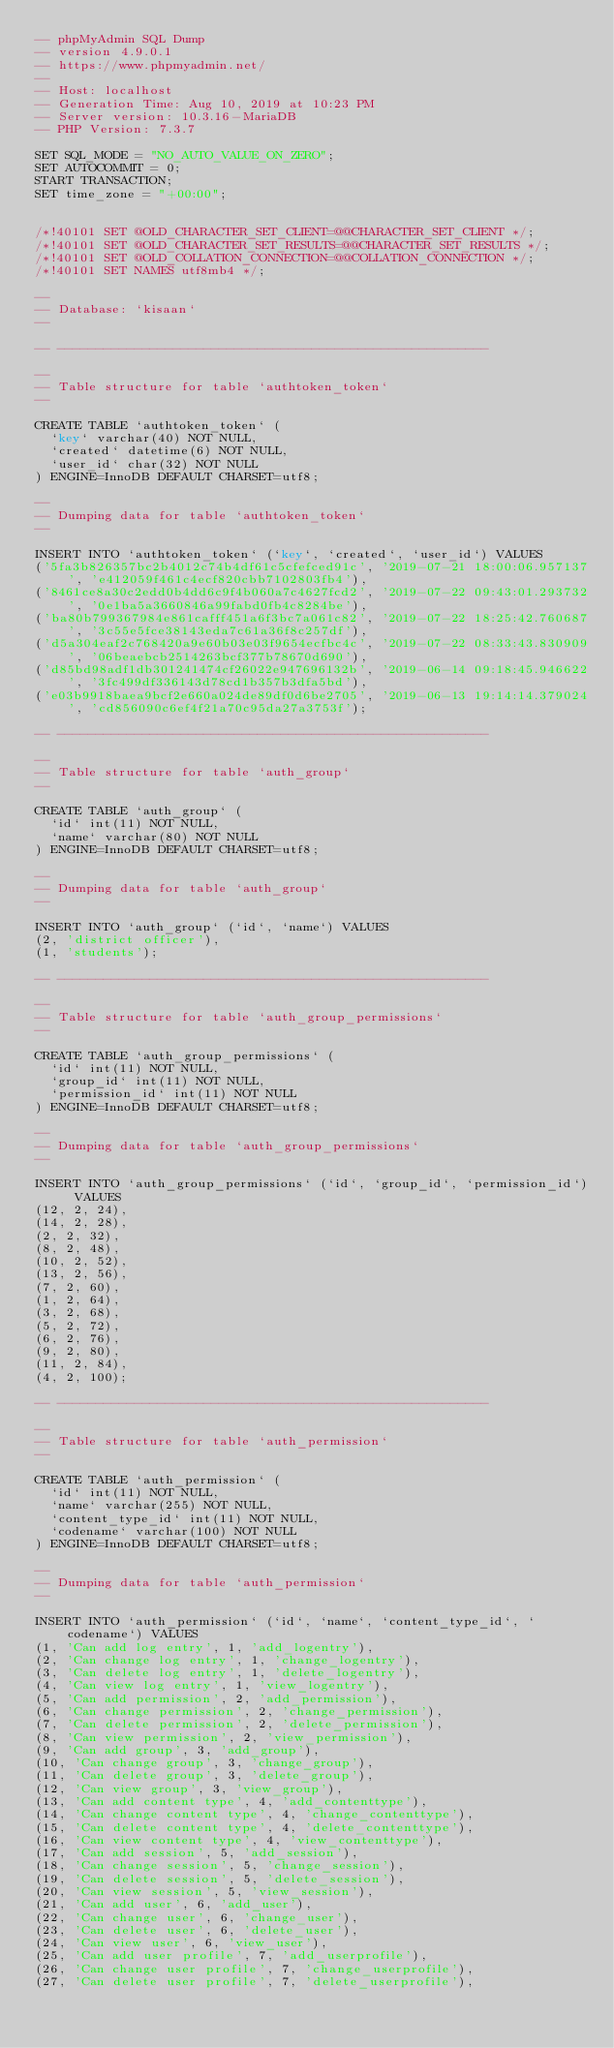Convert code to text. <code><loc_0><loc_0><loc_500><loc_500><_SQL_>-- phpMyAdmin SQL Dump
-- version 4.9.0.1
-- https://www.phpmyadmin.net/
--
-- Host: localhost
-- Generation Time: Aug 10, 2019 at 10:23 PM
-- Server version: 10.3.16-MariaDB
-- PHP Version: 7.3.7

SET SQL_MODE = "NO_AUTO_VALUE_ON_ZERO";
SET AUTOCOMMIT = 0;
START TRANSACTION;
SET time_zone = "+00:00";


/*!40101 SET @OLD_CHARACTER_SET_CLIENT=@@CHARACTER_SET_CLIENT */;
/*!40101 SET @OLD_CHARACTER_SET_RESULTS=@@CHARACTER_SET_RESULTS */;
/*!40101 SET @OLD_COLLATION_CONNECTION=@@COLLATION_CONNECTION */;
/*!40101 SET NAMES utf8mb4 */;

--
-- Database: `kisaan`
--

-- --------------------------------------------------------

--
-- Table structure for table `authtoken_token`
--

CREATE TABLE `authtoken_token` (
  `key` varchar(40) NOT NULL,
  `created` datetime(6) NOT NULL,
  `user_id` char(32) NOT NULL
) ENGINE=InnoDB DEFAULT CHARSET=utf8;

--
-- Dumping data for table `authtoken_token`
--

INSERT INTO `authtoken_token` (`key`, `created`, `user_id`) VALUES
('5fa3b826357bc2b4012c74b4df61c5cfefced91c', '2019-07-21 18:00:06.957137', 'e412059f461c4ecf820cbb7102803fb4'),
('8461ce8a30c2edd0b4dd6c9f4b060a7c4627fcd2', '2019-07-22 09:43:01.293732', '0e1ba5a3660846a99fabd0fb4c8284be'),
('ba80b799367984e861cafff451a6f3bc7a061c82', '2019-07-22 18:25:42.760687', '3c55e5fce38143eda7c61a36f8c257df'),
('d5a304eaf2c768420a9e60b03e03f9654ecfbc4c', '2019-07-22 08:33:43.830909', '06beaebcb2514263bcf377b78670d690'),
('d85bd98adf1db301241474cf26022e947696132b', '2019-06-14 09:18:45.946622', '3fc499df336143d78cd1b357b3dfa5bd'),
('e03b9918baea9bcf2e660a024de89df0d6be2705', '2019-06-13 19:14:14.379024', 'cd856090c6ef4f21a70c95da27a3753f');

-- --------------------------------------------------------

--
-- Table structure for table `auth_group`
--

CREATE TABLE `auth_group` (
  `id` int(11) NOT NULL,
  `name` varchar(80) NOT NULL
) ENGINE=InnoDB DEFAULT CHARSET=utf8;

--
-- Dumping data for table `auth_group`
--

INSERT INTO `auth_group` (`id`, `name`) VALUES
(2, 'district officer'),
(1, 'students');

-- --------------------------------------------------------

--
-- Table structure for table `auth_group_permissions`
--

CREATE TABLE `auth_group_permissions` (
  `id` int(11) NOT NULL,
  `group_id` int(11) NOT NULL,
  `permission_id` int(11) NOT NULL
) ENGINE=InnoDB DEFAULT CHARSET=utf8;

--
-- Dumping data for table `auth_group_permissions`
--

INSERT INTO `auth_group_permissions` (`id`, `group_id`, `permission_id`) VALUES
(12, 2, 24),
(14, 2, 28),
(2, 2, 32),
(8, 2, 48),
(10, 2, 52),
(13, 2, 56),
(7, 2, 60),
(1, 2, 64),
(3, 2, 68),
(5, 2, 72),
(6, 2, 76),
(9, 2, 80),
(11, 2, 84),
(4, 2, 100);

-- --------------------------------------------------------

--
-- Table structure for table `auth_permission`
--

CREATE TABLE `auth_permission` (
  `id` int(11) NOT NULL,
  `name` varchar(255) NOT NULL,
  `content_type_id` int(11) NOT NULL,
  `codename` varchar(100) NOT NULL
) ENGINE=InnoDB DEFAULT CHARSET=utf8;

--
-- Dumping data for table `auth_permission`
--

INSERT INTO `auth_permission` (`id`, `name`, `content_type_id`, `codename`) VALUES
(1, 'Can add log entry', 1, 'add_logentry'),
(2, 'Can change log entry', 1, 'change_logentry'),
(3, 'Can delete log entry', 1, 'delete_logentry'),
(4, 'Can view log entry', 1, 'view_logentry'),
(5, 'Can add permission', 2, 'add_permission'),
(6, 'Can change permission', 2, 'change_permission'),
(7, 'Can delete permission', 2, 'delete_permission'),
(8, 'Can view permission', 2, 'view_permission'),
(9, 'Can add group', 3, 'add_group'),
(10, 'Can change group', 3, 'change_group'),
(11, 'Can delete group', 3, 'delete_group'),
(12, 'Can view group', 3, 'view_group'),
(13, 'Can add content type', 4, 'add_contenttype'),
(14, 'Can change content type', 4, 'change_contenttype'),
(15, 'Can delete content type', 4, 'delete_contenttype'),
(16, 'Can view content type', 4, 'view_contenttype'),
(17, 'Can add session', 5, 'add_session'),
(18, 'Can change session', 5, 'change_session'),
(19, 'Can delete session', 5, 'delete_session'),
(20, 'Can view session', 5, 'view_session'),
(21, 'Can add user', 6, 'add_user'),
(22, 'Can change user', 6, 'change_user'),
(23, 'Can delete user', 6, 'delete_user'),
(24, 'Can view user', 6, 'view_user'),
(25, 'Can add user profile', 7, 'add_userprofile'),
(26, 'Can change user profile', 7, 'change_userprofile'),
(27, 'Can delete user profile', 7, 'delete_userprofile'),</code> 